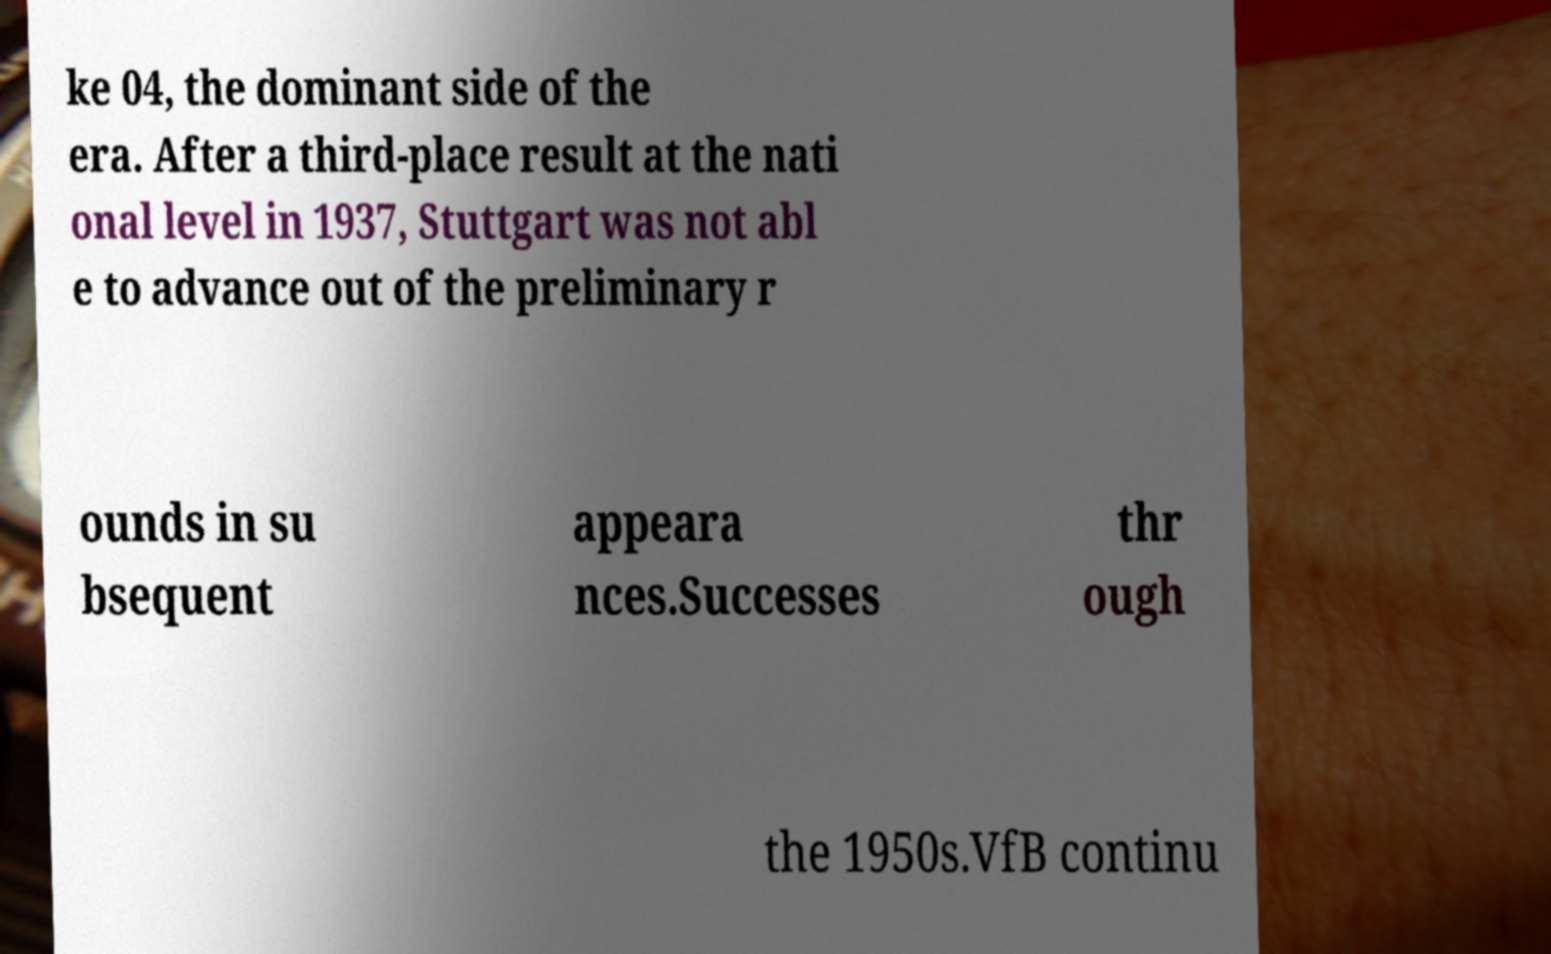Please identify and transcribe the text found in this image. ke 04, the dominant side of the era. After a third-place result at the nati onal level in 1937, Stuttgart was not abl e to advance out of the preliminary r ounds in su bsequent appeara nces.Successes thr ough the 1950s.VfB continu 